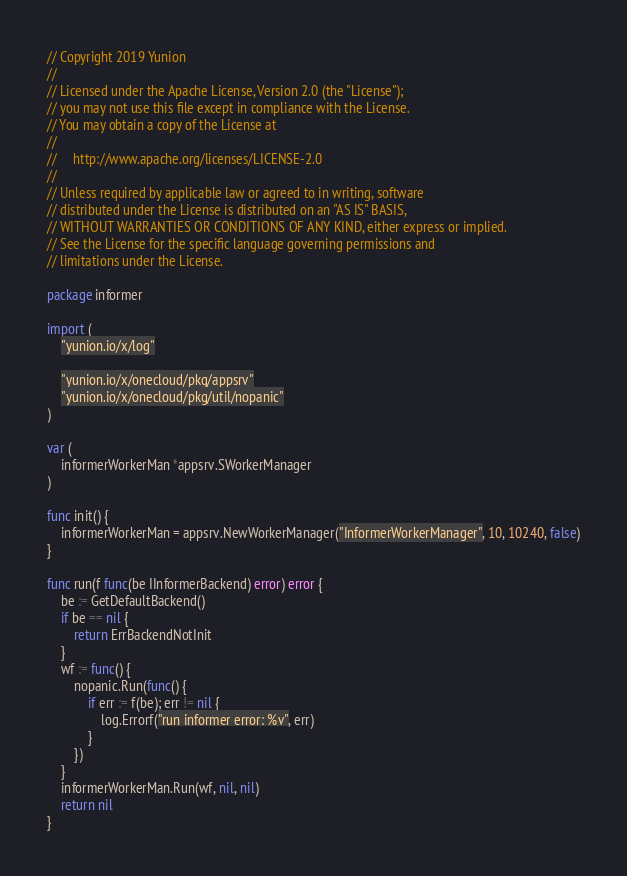Convert code to text. <code><loc_0><loc_0><loc_500><loc_500><_Go_>// Copyright 2019 Yunion
//
// Licensed under the Apache License, Version 2.0 (the "License");
// you may not use this file except in compliance with the License.
// You may obtain a copy of the License at
//
//     http://www.apache.org/licenses/LICENSE-2.0
//
// Unless required by applicable law or agreed to in writing, software
// distributed under the License is distributed on an "AS IS" BASIS,
// WITHOUT WARRANTIES OR CONDITIONS OF ANY KIND, either express or implied.
// See the License for the specific language governing permissions and
// limitations under the License.

package informer

import (
	"yunion.io/x/log"

	"yunion.io/x/onecloud/pkg/appsrv"
	"yunion.io/x/onecloud/pkg/util/nopanic"
)

var (
	informerWorkerMan *appsrv.SWorkerManager
)

func init() {
	informerWorkerMan = appsrv.NewWorkerManager("InformerWorkerManager", 10, 10240, false)
}

func run(f func(be IInformerBackend) error) error {
	be := GetDefaultBackend()
	if be == nil {
		return ErrBackendNotInit
	}
	wf := func() {
		nopanic.Run(func() {
			if err := f(be); err != nil {
				log.Errorf("run informer error: %v", err)
			}
		})
	}
	informerWorkerMan.Run(wf, nil, nil)
	return nil
}
</code> 